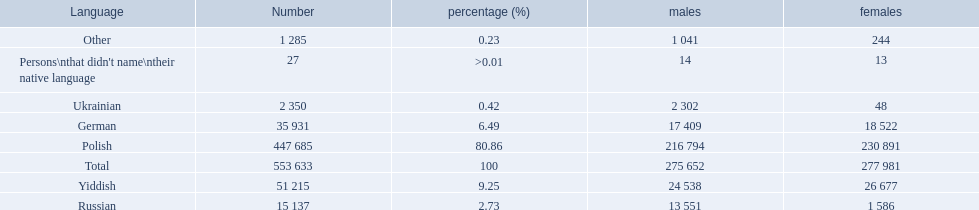What language makes a majority Polish. What the the total number of speakers? 553 633. 